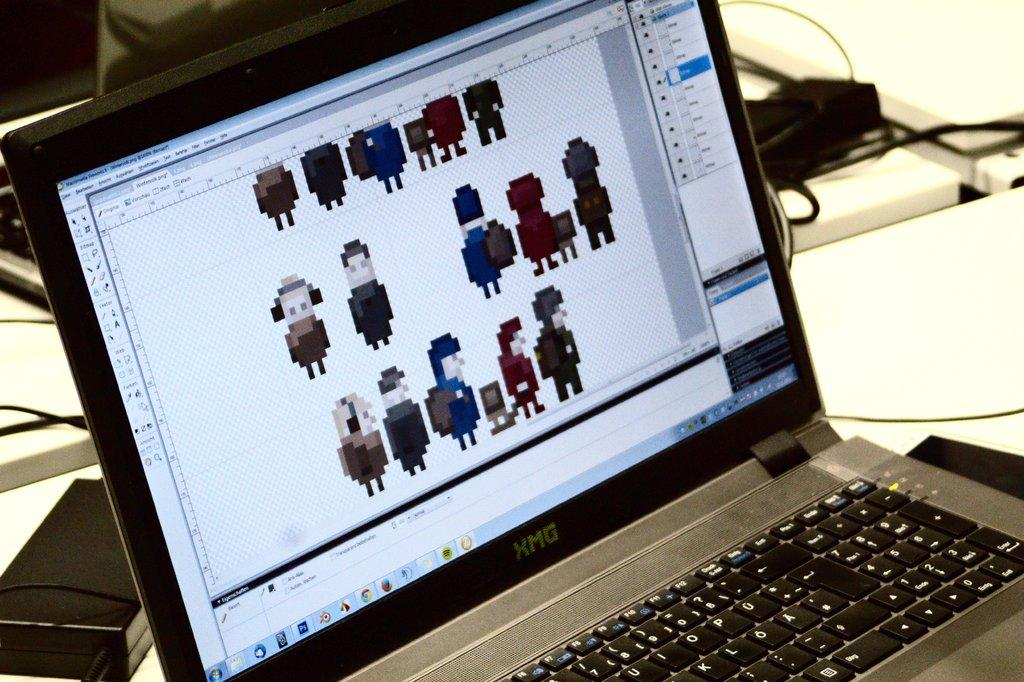Provide a one-sentence caption for the provided image. A small older laptop computer has an XMG logo. 